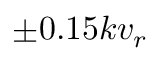<formula> <loc_0><loc_0><loc_500><loc_500>\pm 0 . 1 5 k v _ { r }</formula> 